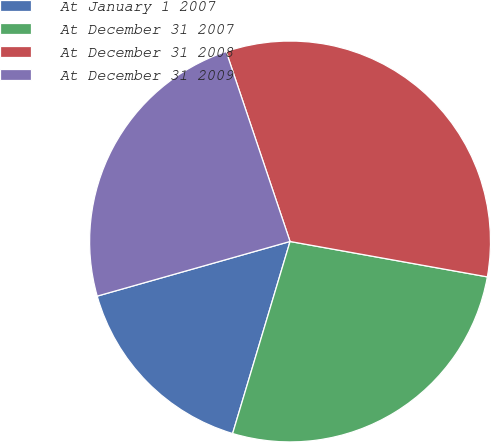Convert chart to OTSL. <chart><loc_0><loc_0><loc_500><loc_500><pie_chart><fcel>At January 1 2007<fcel>At December 31 2007<fcel>At December 31 2008<fcel>At December 31 2009<nl><fcel>15.98%<fcel>26.8%<fcel>32.99%<fcel>24.23%<nl></chart> 